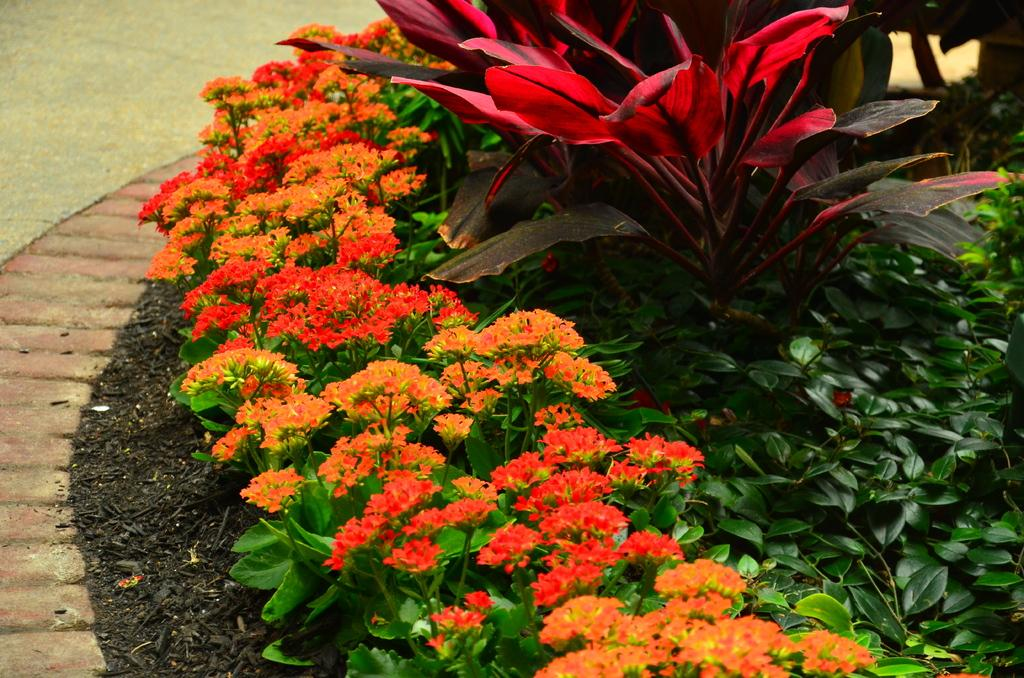What type of living organisms can be seen in the image? There are flowers and plants visible in the image. Can you describe the plants in the image? The plants in the image are not specified, but they are present alongside the flowers. What type of verse can be seen written on the seashore in the image? There is no seashore or verse present in the image; it features flowers and plants. How does the stomach of the plant appear in the image? There is no plant with a visible stomach in the image; the plants are not specified in detail. 